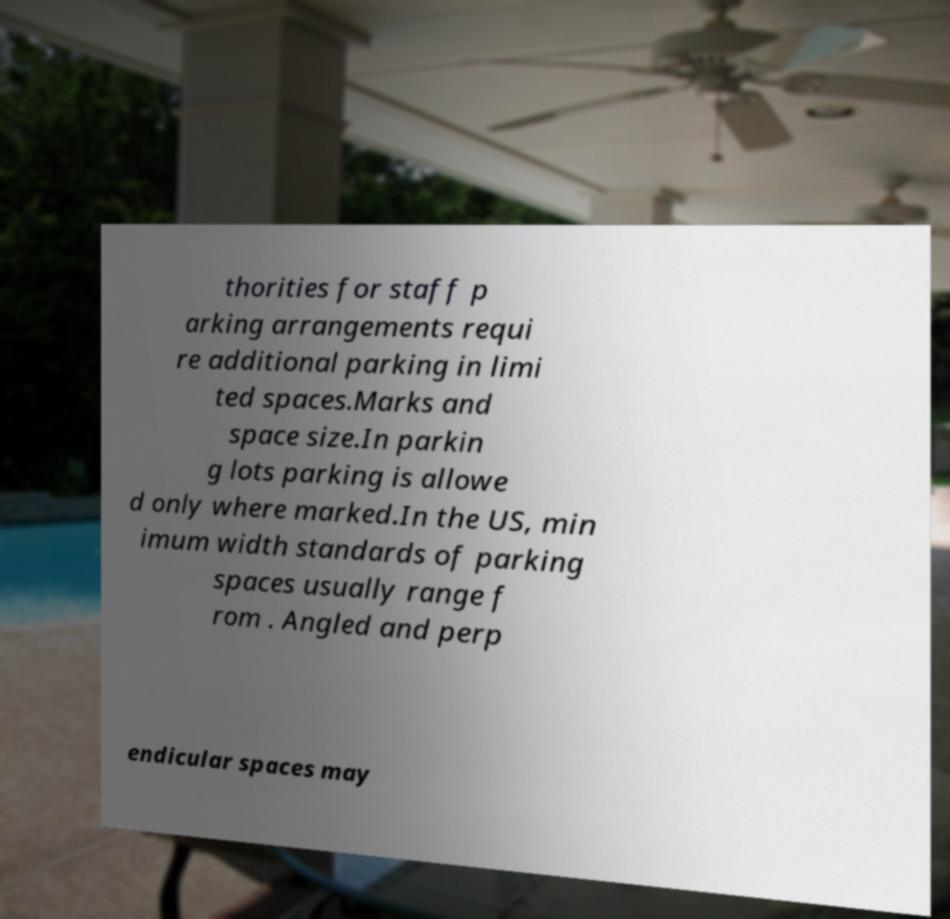I need the written content from this picture converted into text. Can you do that? thorities for staff p arking arrangements requi re additional parking in limi ted spaces.Marks and space size.In parkin g lots parking is allowe d only where marked.In the US, min imum width standards of parking spaces usually range f rom . Angled and perp endicular spaces may 